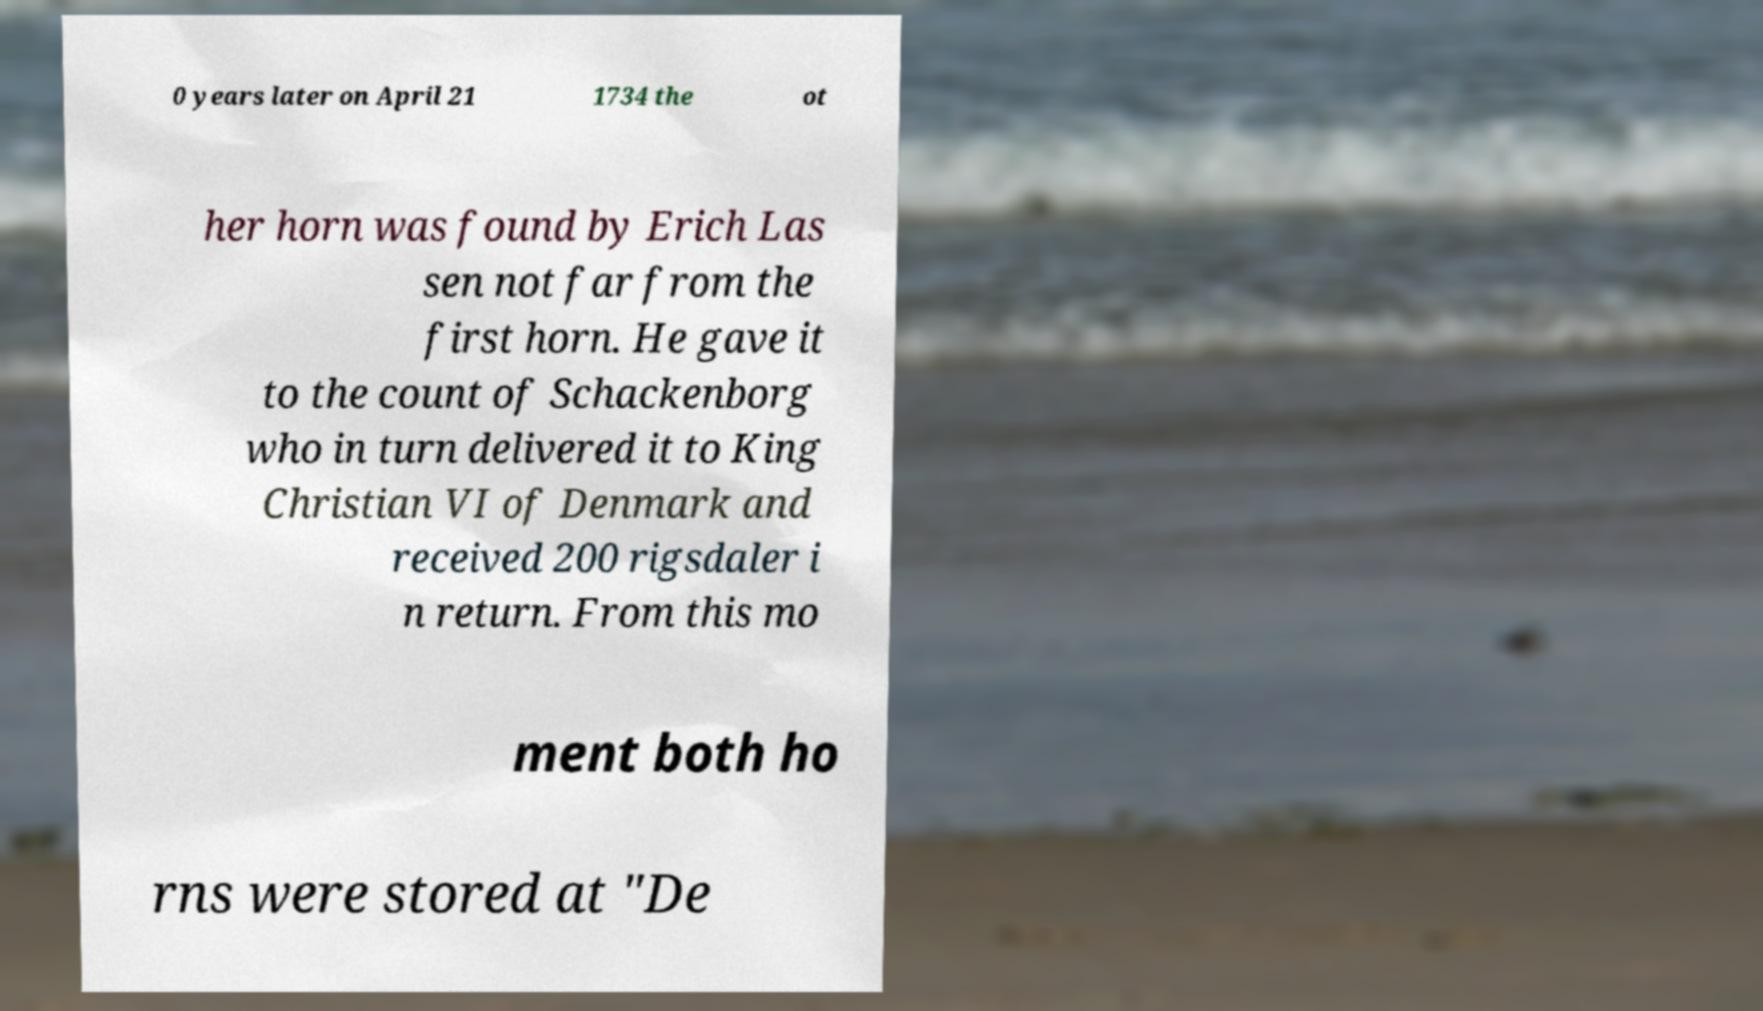Could you assist in decoding the text presented in this image and type it out clearly? 0 years later on April 21 1734 the ot her horn was found by Erich Las sen not far from the first horn. He gave it to the count of Schackenborg who in turn delivered it to King Christian VI of Denmark and received 200 rigsdaler i n return. From this mo ment both ho rns were stored at "De 